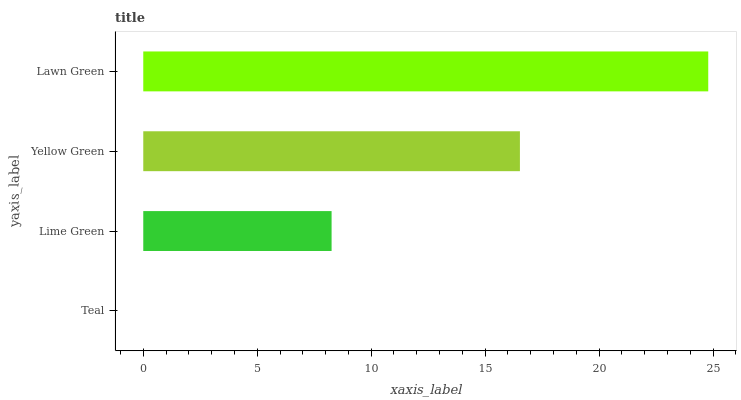Is Teal the minimum?
Answer yes or no. Yes. Is Lawn Green the maximum?
Answer yes or no. Yes. Is Lime Green the minimum?
Answer yes or no. No. Is Lime Green the maximum?
Answer yes or no. No. Is Lime Green greater than Teal?
Answer yes or no. Yes. Is Teal less than Lime Green?
Answer yes or no. Yes. Is Teal greater than Lime Green?
Answer yes or no. No. Is Lime Green less than Teal?
Answer yes or no. No. Is Yellow Green the high median?
Answer yes or no. Yes. Is Lime Green the low median?
Answer yes or no. Yes. Is Lawn Green the high median?
Answer yes or no. No. Is Lawn Green the low median?
Answer yes or no. No. 